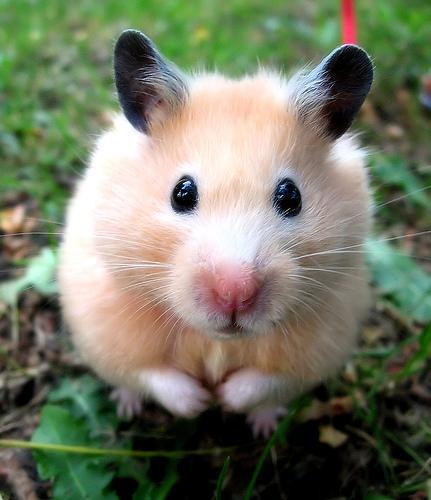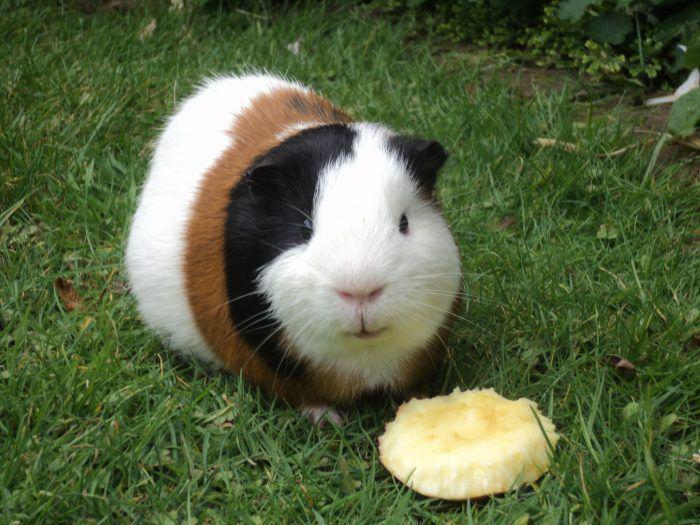The first image is the image on the left, the second image is the image on the right. Assess this claim about the two images: "At least one of the images is of a single guinea pig laying in the grass.". Correct or not? Answer yes or no. Yes. The first image is the image on the left, the second image is the image on the right. Given the left and right images, does the statement "The guinea pig is sitting on the grass." hold true? Answer yes or no. Yes. 